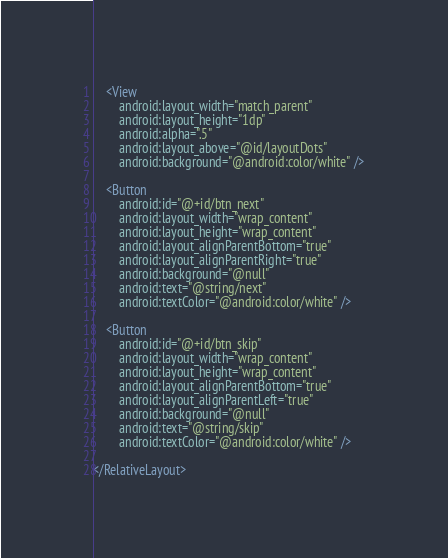<code> <loc_0><loc_0><loc_500><loc_500><_XML_>    <View
        android:layout_width="match_parent"
        android:layout_height="1dp"
        android:alpha=".5"
        android:layout_above="@id/layoutDots"
        android:background="@android:color/white" />

    <Button
        android:id="@+id/btn_next"
        android:layout_width="wrap_content"
        android:layout_height="wrap_content"
        android:layout_alignParentBottom="true"
        android:layout_alignParentRight="true"
        android:background="@null"
        android:text="@string/next"
        android:textColor="@android:color/white" />

    <Button
        android:id="@+id/btn_skip"
        android:layout_width="wrap_content"
        android:layout_height="wrap_content"
        android:layout_alignParentBottom="true"
        android:layout_alignParentLeft="true"
        android:background="@null"
        android:text="@string/skip"
        android:textColor="@android:color/white" />

</RelativeLayout></code> 